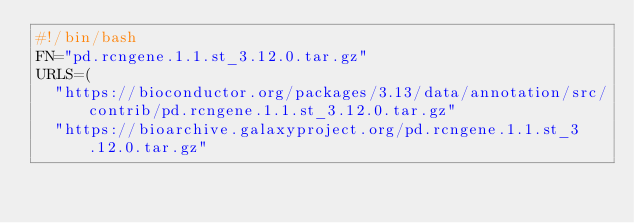Convert code to text. <code><loc_0><loc_0><loc_500><loc_500><_Bash_>#!/bin/bash
FN="pd.rcngene.1.1.st_3.12.0.tar.gz"
URLS=(
  "https://bioconductor.org/packages/3.13/data/annotation/src/contrib/pd.rcngene.1.1.st_3.12.0.tar.gz"
  "https://bioarchive.galaxyproject.org/pd.rcngene.1.1.st_3.12.0.tar.gz"</code> 